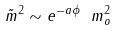Convert formula to latex. <formula><loc_0><loc_0><loc_500><loc_500>\tilde { m } ^ { 2 } \sim e ^ { - a \phi } \ m ^ { 2 } _ { o }</formula> 